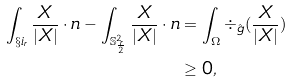<formula> <loc_0><loc_0><loc_500><loc_500>\int _ { \S i _ { r } } \frac { X } { | X | } \cdot n - \int _ { \mathbb { S } ^ { 2 } _ { \frac { r } { 2 } } } \frac { X } { | X | } \cdot n & = \int _ { \Omega } \div _ { \hat { g } } ( \frac { X } { | X | } ) \\ & \geq 0 ,</formula> 